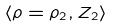<formula> <loc_0><loc_0><loc_500><loc_500>\langle \rho = \rho _ { 2 } , Z _ { 2 } \rangle</formula> 